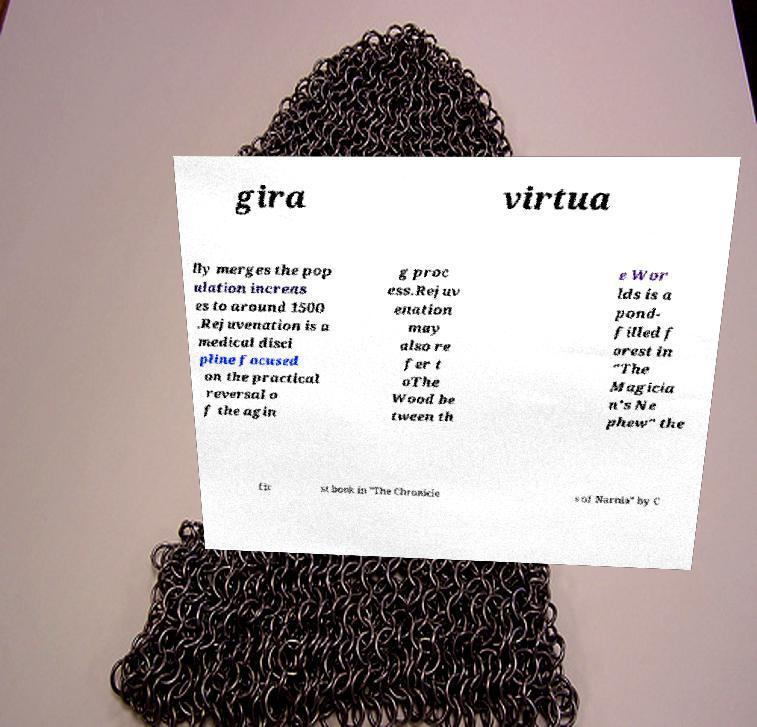I need the written content from this picture converted into text. Can you do that? gira virtua lly merges the pop ulation increas es to around 1500 .Rejuvenation is a medical disci pline focused on the practical reversal o f the agin g proc ess.Rejuv enation may also re fer t oThe Wood be tween th e Wor lds is a pond- filled f orest in "The Magicia n's Ne phew" the fir st book in "The Chronicle s of Narnia" by C 